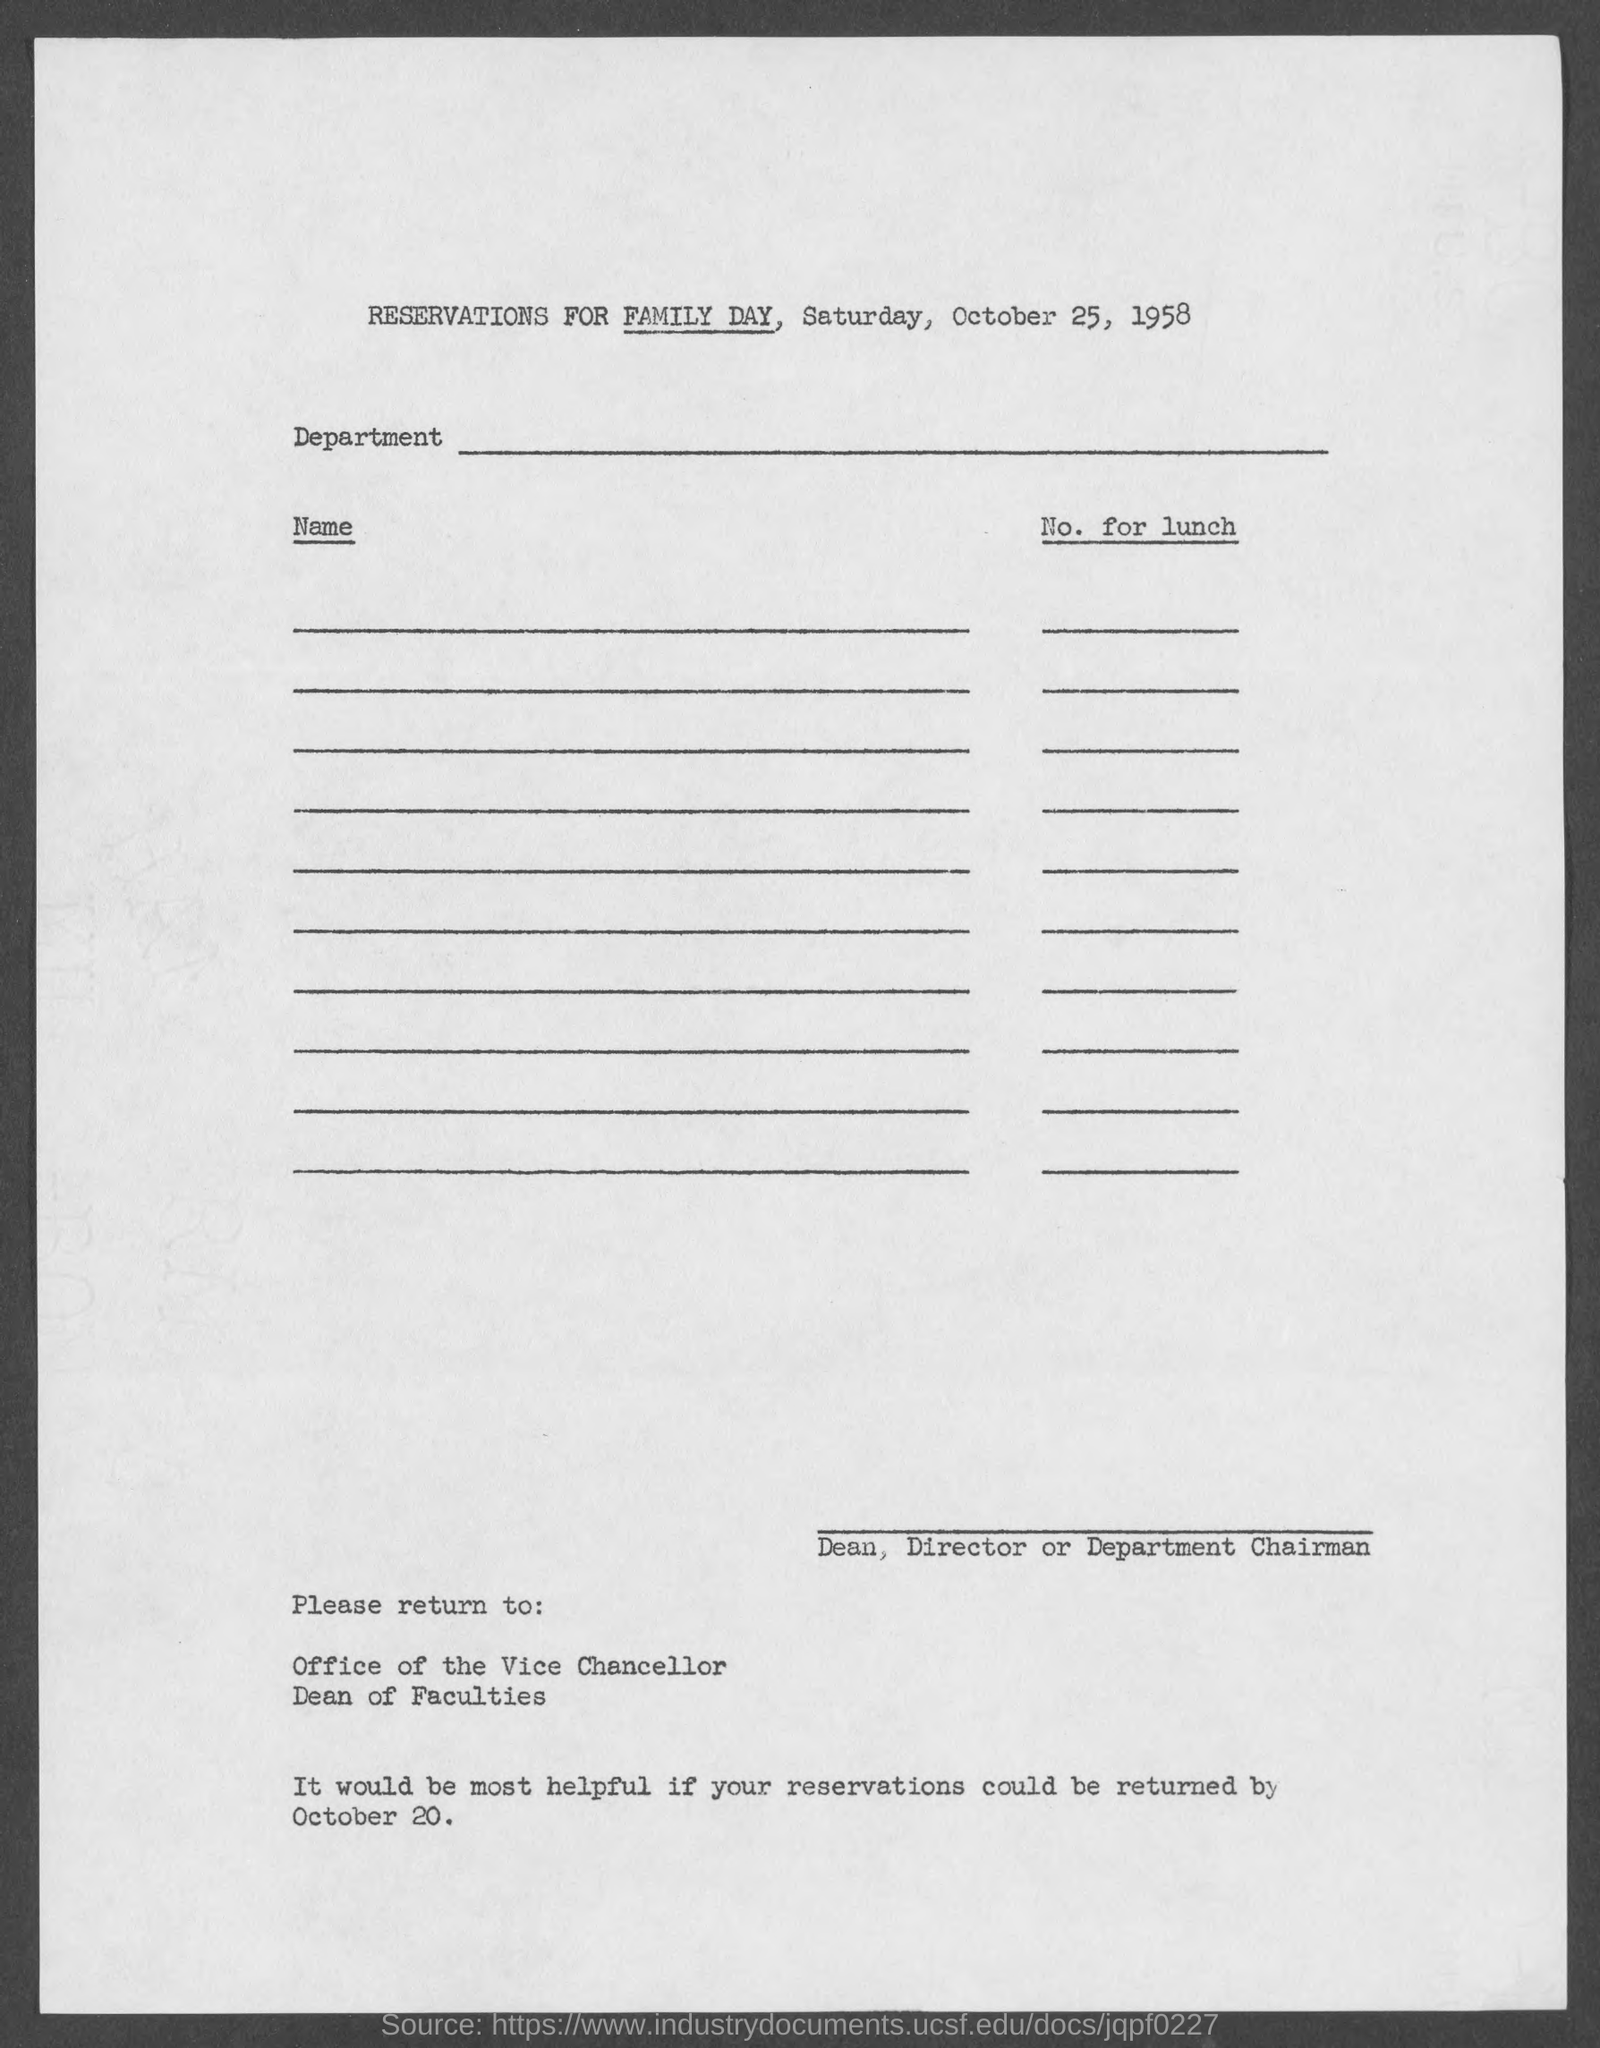What was the function mentioned in this resevation form?
Ensure brevity in your answer.  FAMILY DAY. Which was the year mentioned in the title?
Your answer should be compact. 1958. What was the last day to return the reservation form?
Provide a succinct answer. October 20. 